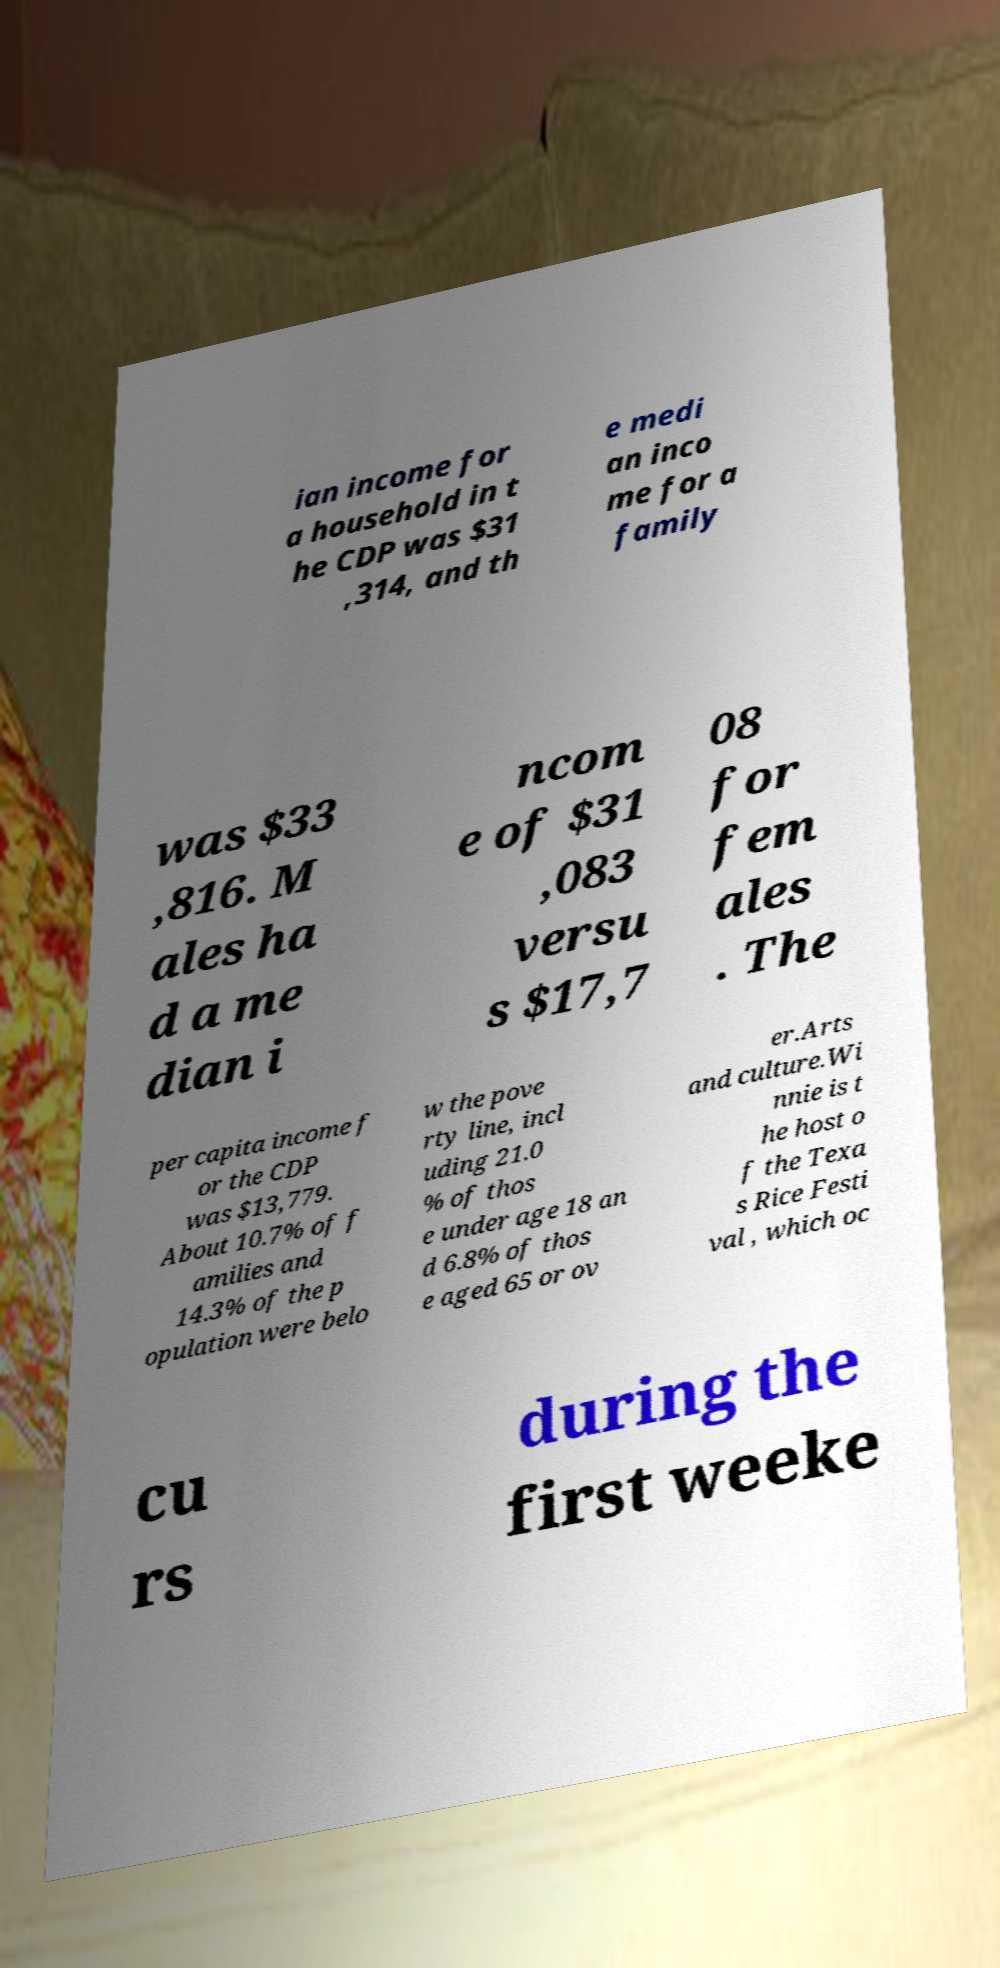I need the written content from this picture converted into text. Can you do that? ian income for a household in t he CDP was $31 ,314, and th e medi an inco me for a family was $33 ,816. M ales ha d a me dian i ncom e of $31 ,083 versu s $17,7 08 for fem ales . The per capita income f or the CDP was $13,779. About 10.7% of f amilies and 14.3% of the p opulation were belo w the pove rty line, incl uding 21.0 % of thos e under age 18 an d 6.8% of thos e aged 65 or ov er.Arts and culture.Wi nnie is t he host o f the Texa s Rice Festi val , which oc cu rs during the first weeke 